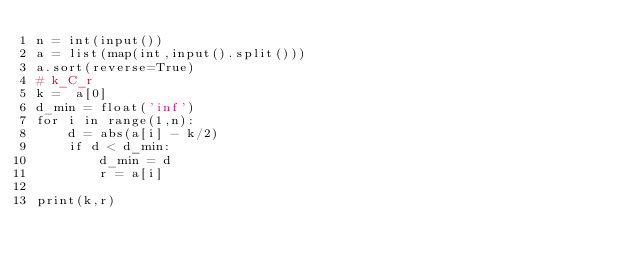Convert code to text. <code><loc_0><loc_0><loc_500><loc_500><_Python_>n = int(input())
a = list(map(int,input().split()))
a.sort(reverse=True)
# k_C_r
k =  a[0]
d_min = float('inf')
for i in range(1,n):
    d = abs(a[i] - k/2)
    if d < d_min:
        d_min = d
        r = a[i]

print(k,r)</code> 